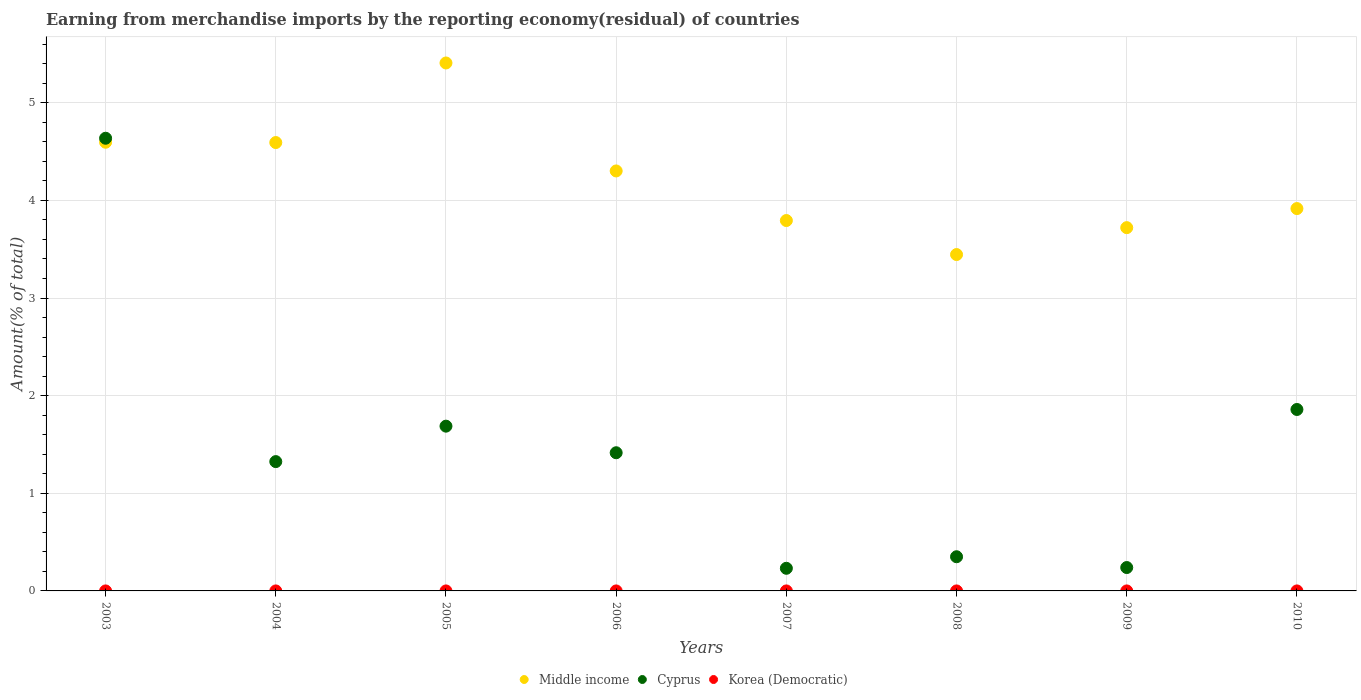How many different coloured dotlines are there?
Your response must be concise. 3. What is the percentage of amount earned from merchandise imports in Cyprus in 2006?
Provide a short and direct response. 1.42. Across all years, what is the maximum percentage of amount earned from merchandise imports in Korea (Democratic)?
Make the answer very short. 1.30511509646857e-8. Across all years, what is the minimum percentage of amount earned from merchandise imports in Cyprus?
Make the answer very short. 0.23. What is the total percentage of amount earned from merchandise imports in Korea (Democratic) in the graph?
Make the answer very short. 1.497962723188751e-8. What is the difference between the percentage of amount earned from merchandise imports in Cyprus in 2003 and that in 2010?
Ensure brevity in your answer.  2.78. What is the difference between the percentage of amount earned from merchandise imports in Middle income in 2006 and the percentage of amount earned from merchandise imports in Korea (Democratic) in 2004?
Your response must be concise. 4.3. What is the average percentage of amount earned from merchandise imports in Middle income per year?
Provide a short and direct response. 4.22. In the year 2004, what is the difference between the percentage of amount earned from merchandise imports in Cyprus and percentage of amount earned from merchandise imports in Middle income?
Your answer should be compact. -3.27. In how many years, is the percentage of amount earned from merchandise imports in Cyprus greater than 2.8 %?
Your answer should be very brief. 1. What is the ratio of the percentage of amount earned from merchandise imports in Cyprus in 2003 to that in 2009?
Offer a terse response. 19.36. Is the difference between the percentage of amount earned from merchandise imports in Cyprus in 2008 and 2010 greater than the difference between the percentage of amount earned from merchandise imports in Middle income in 2008 and 2010?
Your answer should be compact. No. What is the difference between the highest and the second highest percentage of amount earned from merchandise imports in Korea (Democratic)?
Give a very brief answer. 1.152774784415054e-8. What is the difference between the highest and the lowest percentage of amount earned from merchandise imports in Cyprus?
Make the answer very short. 4.41. Is it the case that in every year, the sum of the percentage of amount earned from merchandise imports in Korea (Democratic) and percentage of amount earned from merchandise imports in Middle income  is greater than the percentage of amount earned from merchandise imports in Cyprus?
Offer a very short reply. No. Is the percentage of amount earned from merchandise imports in Korea (Democratic) strictly greater than the percentage of amount earned from merchandise imports in Cyprus over the years?
Ensure brevity in your answer.  No. How many dotlines are there?
Your response must be concise. 3. How many years are there in the graph?
Offer a very short reply. 8. What is the difference between two consecutive major ticks on the Y-axis?
Provide a succinct answer. 1. Where does the legend appear in the graph?
Your answer should be compact. Bottom center. What is the title of the graph?
Provide a succinct answer. Earning from merchandise imports by the reporting economy(residual) of countries. Does "Italy" appear as one of the legend labels in the graph?
Make the answer very short. No. What is the label or title of the X-axis?
Provide a succinct answer. Years. What is the label or title of the Y-axis?
Offer a very short reply. Amount(% of total). What is the Amount(% of total) of Middle income in 2003?
Keep it short and to the point. 4.6. What is the Amount(% of total) of Cyprus in 2003?
Provide a succinct answer. 4.64. What is the Amount(% of total) of Korea (Democratic) in 2003?
Keep it short and to the point. 0. What is the Amount(% of total) of Middle income in 2004?
Provide a short and direct response. 4.59. What is the Amount(% of total) in Cyprus in 2004?
Keep it short and to the point. 1.32. What is the Amount(% of total) in Korea (Democratic) in 2004?
Your response must be concise. 1.30511509646857e-8. What is the Amount(% of total) in Middle income in 2005?
Make the answer very short. 5.41. What is the Amount(% of total) in Cyprus in 2005?
Offer a terse response. 1.69. What is the Amount(% of total) in Korea (Democratic) in 2005?
Offer a terse response. 0. What is the Amount(% of total) of Middle income in 2006?
Provide a short and direct response. 4.3. What is the Amount(% of total) of Cyprus in 2006?
Offer a terse response. 1.42. What is the Amount(% of total) in Korea (Democratic) in 2006?
Provide a succinct answer. 4.05073146666651e-10. What is the Amount(% of total) of Middle income in 2007?
Keep it short and to the point. 3.79. What is the Amount(% of total) of Cyprus in 2007?
Provide a succinct answer. 0.23. What is the Amount(% of total) of Middle income in 2008?
Your answer should be compact. 3.45. What is the Amount(% of total) in Cyprus in 2008?
Offer a terse response. 0.35. What is the Amount(% of total) of Middle income in 2009?
Offer a very short reply. 3.72. What is the Amount(% of total) in Cyprus in 2009?
Make the answer very short. 0.24. What is the Amount(% of total) in Korea (Democratic) in 2009?
Keep it short and to the point. 1.52340312053516e-9. What is the Amount(% of total) in Middle income in 2010?
Ensure brevity in your answer.  3.92. What is the Amount(% of total) of Cyprus in 2010?
Ensure brevity in your answer.  1.86. What is the Amount(% of total) of Korea (Democratic) in 2010?
Offer a very short reply. 0. Across all years, what is the maximum Amount(% of total) in Middle income?
Ensure brevity in your answer.  5.41. Across all years, what is the maximum Amount(% of total) of Cyprus?
Give a very brief answer. 4.64. Across all years, what is the maximum Amount(% of total) in Korea (Democratic)?
Offer a very short reply. 1.30511509646857e-8. Across all years, what is the minimum Amount(% of total) in Middle income?
Keep it short and to the point. 3.45. Across all years, what is the minimum Amount(% of total) of Cyprus?
Ensure brevity in your answer.  0.23. What is the total Amount(% of total) of Middle income in the graph?
Provide a succinct answer. 33.78. What is the total Amount(% of total) of Cyprus in the graph?
Offer a terse response. 11.74. What is the total Amount(% of total) of Korea (Democratic) in the graph?
Your response must be concise. 0. What is the difference between the Amount(% of total) in Middle income in 2003 and that in 2004?
Provide a short and direct response. 0. What is the difference between the Amount(% of total) of Cyprus in 2003 and that in 2004?
Ensure brevity in your answer.  3.31. What is the difference between the Amount(% of total) of Middle income in 2003 and that in 2005?
Your response must be concise. -0.81. What is the difference between the Amount(% of total) of Cyprus in 2003 and that in 2005?
Your answer should be very brief. 2.95. What is the difference between the Amount(% of total) in Middle income in 2003 and that in 2006?
Offer a very short reply. 0.29. What is the difference between the Amount(% of total) in Cyprus in 2003 and that in 2006?
Your answer should be compact. 3.22. What is the difference between the Amount(% of total) in Middle income in 2003 and that in 2007?
Keep it short and to the point. 0.8. What is the difference between the Amount(% of total) in Cyprus in 2003 and that in 2007?
Make the answer very short. 4.41. What is the difference between the Amount(% of total) in Middle income in 2003 and that in 2008?
Make the answer very short. 1.15. What is the difference between the Amount(% of total) of Cyprus in 2003 and that in 2008?
Your response must be concise. 4.29. What is the difference between the Amount(% of total) of Middle income in 2003 and that in 2009?
Provide a succinct answer. 0.87. What is the difference between the Amount(% of total) of Cyprus in 2003 and that in 2009?
Your response must be concise. 4.4. What is the difference between the Amount(% of total) in Middle income in 2003 and that in 2010?
Provide a succinct answer. 0.68. What is the difference between the Amount(% of total) in Cyprus in 2003 and that in 2010?
Make the answer very short. 2.78. What is the difference between the Amount(% of total) of Middle income in 2004 and that in 2005?
Give a very brief answer. -0.82. What is the difference between the Amount(% of total) in Cyprus in 2004 and that in 2005?
Offer a terse response. -0.36. What is the difference between the Amount(% of total) of Middle income in 2004 and that in 2006?
Ensure brevity in your answer.  0.29. What is the difference between the Amount(% of total) in Cyprus in 2004 and that in 2006?
Your response must be concise. -0.09. What is the difference between the Amount(% of total) in Korea (Democratic) in 2004 and that in 2006?
Keep it short and to the point. 0. What is the difference between the Amount(% of total) in Middle income in 2004 and that in 2007?
Your answer should be compact. 0.8. What is the difference between the Amount(% of total) of Cyprus in 2004 and that in 2007?
Your answer should be compact. 1.09. What is the difference between the Amount(% of total) in Middle income in 2004 and that in 2008?
Provide a succinct answer. 1.15. What is the difference between the Amount(% of total) of Cyprus in 2004 and that in 2008?
Ensure brevity in your answer.  0.97. What is the difference between the Amount(% of total) in Middle income in 2004 and that in 2009?
Make the answer very short. 0.87. What is the difference between the Amount(% of total) of Cyprus in 2004 and that in 2009?
Give a very brief answer. 1.09. What is the difference between the Amount(% of total) of Middle income in 2004 and that in 2010?
Provide a short and direct response. 0.68. What is the difference between the Amount(% of total) of Cyprus in 2004 and that in 2010?
Keep it short and to the point. -0.53. What is the difference between the Amount(% of total) of Middle income in 2005 and that in 2006?
Keep it short and to the point. 1.11. What is the difference between the Amount(% of total) of Cyprus in 2005 and that in 2006?
Ensure brevity in your answer.  0.27. What is the difference between the Amount(% of total) in Middle income in 2005 and that in 2007?
Make the answer very short. 1.61. What is the difference between the Amount(% of total) in Cyprus in 2005 and that in 2007?
Provide a short and direct response. 1.46. What is the difference between the Amount(% of total) in Middle income in 2005 and that in 2008?
Ensure brevity in your answer.  1.96. What is the difference between the Amount(% of total) of Cyprus in 2005 and that in 2008?
Give a very brief answer. 1.34. What is the difference between the Amount(% of total) in Middle income in 2005 and that in 2009?
Give a very brief answer. 1.69. What is the difference between the Amount(% of total) in Cyprus in 2005 and that in 2009?
Give a very brief answer. 1.45. What is the difference between the Amount(% of total) in Middle income in 2005 and that in 2010?
Offer a terse response. 1.49. What is the difference between the Amount(% of total) in Cyprus in 2005 and that in 2010?
Your answer should be very brief. -0.17. What is the difference between the Amount(% of total) in Middle income in 2006 and that in 2007?
Give a very brief answer. 0.51. What is the difference between the Amount(% of total) of Cyprus in 2006 and that in 2007?
Provide a succinct answer. 1.18. What is the difference between the Amount(% of total) in Middle income in 2006 and that in 2008?
Offer a terse response. 0.86. What is the difference between the Amount(% of total) of Cyprus in 2006 and that in 2008?
Give a very brief answer. 1.07. What is the difference between the Amount(% of total) in Middle income in 2006 and that in 2009?
Offer a terse response. 0.58. What is the difference between the Amount(% of total) in Cyprus in 2006 and that in 2009?
Your answer should be very brief. 1.18. What is the difference between the Amount(% of total) of Middle income in 2006 and that in 2010?
Your response must be concise. 0.39. What is the difference between the Amount(% of total) of Cyprus in 2006 and that in 2010?
Give a very brief answer. -0.44. What is the difference between the Amount(% of total) of Middle income in 2007 and that in 2008?
Your answer should be very brief. 0.35. What is the difference between the Amount(% of total) in Cyprus in 2007 and that in 2008?
Keep it short and to the point. -0.12. What is the difference between the Amount(% of total) of Middle income in 2007 and that in 2009?
Your answer should be very brief. 0.07. What is the difference between the Amount(% of total) in Cyprus in 2007 and that in 2009?
Provide a succinct answer. -0.01. What is the difference between the Amount(% of total) in Middle income in 2007 and that in 2010?
Keep it short and to the point. -0.12. What is the difference between the Amount(% of total) of Cyprus in 2007 and that in 2010?
Your answer should be compact. -1.63. What is the difference between the Amount(% of total) in Middle income in 2008 and that in 2009?
Offer a terse response. -0.28. What is the difference between the Amount(% of total) of Cyprus in 2008 and that in 2009?
Offer a terse response. 0.11. What is the difference between the Amount(% of total) of Middle income in 2008 and that in 2010?
Keep it short and to the point. -0.47. What is the difference between the Amount(% of total) of Cyprus in 2008 and that in 2010?
Keep it short and to the point. -1.51. What is the difference between the Amount(% of total) in Middle income in 2009 and that in 2010?
Ensure brevity in your answer.  -0.2. What is the difference between the Amount(% of total) in Cyprus in 2009 and that in 2010?
Give a very brief answer. -1.62. What is the difference between the Amount(% of total) in Middle income in 2003 and the Amount(% of total) in Cyprus in 2004?
Provide a succinct answer. 3.27. What is the difference between the Amount(% of total) in Middle income in 2003 and the Amount(% of total) in Korea (Democratic) in 2004?
Keep it short and to the point. 4.6. What is the difference between the Amount(% of total) in Cyprus in 2003 and the Amount(% of total) in Korea (Democratic) in 2004?
Offer a terse response. 4.64. What is the difference between the Amount(% of total) in Middle income in 2003 and the Amount(% of total) in Cyprus in 2005?
Your answer should be compact. 2.91. What is the difference between the Amount(% of total) of Middle income in 2003 and the Amount(% of total) of Cyprus in 2006?
Your answer should be very brief. 3.18. What is the difference between the Amount(% of total) of Middle income in 2003 and the Amount(% of total) of Korea (Democratic) in 2006?
Your answer should be very brief. 4.6. What is the difference between the Amount(% of total) of Cyprus in 2003 and the Amount(% of total) of Korea (Democratic) in 2006?
Your answer should be very brief. 4.64. What is the difference between the Amount(% of total) in Middle income in 2003 and the Amount(% of total) in Cyprus in 2007?
Give a very brief answer. 4.36. What is the difference between the Amount(% of total) in Middle income in 2003 and the Amount(% of total) in Cyprus in 2008?
Give a very brief answer. 4.25. What is the difference between the Amount(% of total) in Middle income in 2003 and the Amount(% of total) in Cyprus in 2009?
Your response must be concise. 4.36. What is the difference between the Amount(% of total) in Middle income in 2003 and the Amount(% of total) in Korea (Democratic) in 2009?
Your response must be concise. 4.6. What is the difference between the Amount(% of total) of Cyprus in 2003 and the Amount(% of total) of Korea (Democratic) in 2009?
Provide a succinct answer. 4.64. What is the difference between the Amount(% of total) in Middle income in 2003 and the Amount(% of total) in Cyprus in 2010?
Make the answer very short. 2.74. What is the difference between the Amount(% of total) of Middle income in 2004 and the Amount(% of total) of Cyprus in 2005?
Keep it short and to the point. 2.91. What is the difference between the Amount(% of total) in Middle income in 2004 and the Amount(% of total) in Cyprus in 2006?
Your answer should be compact. 3.18. What is the difference between the Amount(% of total) in Middle income in 2004 and the Amount(% of total) in Korea (Democratic) in 2006?
Keep it short and to the point. 4.59. What is the difference between the Amount(% of total) in Cyprus in 2004 and the Amount(% of total) in Korea (Democratic) in 2006?
Give a very brief answer. 1.32. What is the difference between the Amount(% of total) in Middle income in 2004 and the Amount(% of total) in Cyprus in 2007?
Your answer should be very brief. 4.36. What is the difference between the Amount(% of total) in Middle income in 2004 and the Amount(% of total) in Cyprus in 2008?
Give a very brief answer. 4.24. What is the difference between the Amount(% of total) of Middle income in 2004 and the Amount(% of total) of Cyprus in 2009?
Ensure brevity in your answer.  4.35. What is the difference between the Amount(% of total) in Middle income in 2004 and the Amount(% of total) in Korea (Democratic) in 2009?
Your answer should be compact. 4.59. What is the difference between the Amount(% of total) in Cyprus in 2004 and the Amount(% of total) in Korea (Democratic) in 2009?
Give a very brief answer. 1.32. What is the difference between the Amount(% of total) in Middle income in 2004 and the Amount(% of total) in Cyprus in 2010?
Ensure brevity in your answer.  2.73. What is the difference between the Amount(% of total) in Middle income in 2005 and the Amount(% of total) in Cyprus in 2006?
Keep it short and to the point. 3.99. What is the difference between the Amount(% of total) of Middle income in 2005 and the Amount(% of total) of Korea (Democratic) in 2006?
Give a very brief answer. 5.41. What is the difference between the Amount(% of total) in Cyprus in 2005 and the Amount(% of total) in Korea (Democratic) in 2006?
Keep it short and to the point. 1.69. What is the difference between the Amount(% of total) in Middle income in 2005 and the Amount(% of total) in Cyprus in 2007?
Your answer should be compact. 5.18. What is the difference between the Amount(% of total) in Middle income in 2005 and the Amount(% of total) in Cyprus in 2008?
Provide a succinct answer. 5.06. What is the difference between the Amount(% of total) of Middle income in 2005 and the Amount(% of total) of Cyprus in 2009?
Give a very brief answer. 5.17. What is the difference between the Amount(% of total) in Middle income in 2005 and the Amount(% of total) in Korea (Democratic) in 2009?
Your response must be concise. 5.41. What is the difference between the Amount(% of total) of Cyprus in 2005 and the Amount(% of total) of Korea (Democratic) in 2009?
Keep it short and to the point. 1.69. What is the difference between the Amount(% of total) of Middle income in 2005 and the Amount(% of total) of Cyprus in 2010?
Give a very brief answer. 3.55. What is the difference between the Amount(% of total) of Middle income in 2006 and the Amount(% of total) of Cyprus in 2007?
Ensure brevity in your answer.  4.07. What is the difference between the Amount(% of total) of Middle income in 2006 and the Amount(% of total) of Cyprus in 2008?
Make the answer very short. 3.95. What is the difference between the Amount(% of total) of Middle income in 2006 and the Amount(% of total) of Cyprus in 2009?
Your answer should be compact. 4.06. What is the difference between the Amount(% of total) in Middle income in 2006 and the Amount(% of total) in Korea (Democratic) in 2009?
Offer a very short reply. 4.3. What is the difference between the Amount(% of total) in Cyprus in 2006 and the Amount(% of total) in Korea (Democratic) in 2009?
Offer a terse response. 1.42. What is the difference between the Amount(% of total) of Middle income in 2006 and the Amount(% of total) of Cyprus in 2010?
Keep it short and to the point. 2.44. What is the difference between the Amount(% of total) of Middle income in 2007 and the Amount(% of total) of Cyprus in 2008?
Provide a succinct answer. 3.44. What is the difference between the Amount(% of total) of Middle income in 2007 and the Amount(% of total) of Cyprus in 2009?
Your response must be concise. 3.55. What is the difference between the Amount(% of total) of Middle income in 2007 and the Amount(% of total) of Korea (Democratic) in 2009?
Your response must be concise. 3.79. What is the difference between the Amount(% of total) in Cyprus in 2007 and the Amount(% of total) in Korea (Democratic) in 2009?
Ensure brevity in your answer.  0.23. What is the difference between the Amount(% of total) in Middle income in 2007 and the Amount(% of total) in Cyprus in 2010?
Your answer should be compact. 1.94. What is the difference between the Amount(% of total) in Middle income in 2008 and the Amount(% of total) in Cyprus in 2009?
Your answer should be very brief. 3.21. What is the difference between the Amount(% of total) of Middle income in 2008 and the Amount(% of total) of Korea (Democratic) in 2009?
Provide a succinct answer. 3.45. What is the difference between the Amount(% of total) of Cyprus in 2008 and the Amount(% of total) of Korea (Democratic) in 2009?
Give a very brief answer. 0.35. What is the difference between the Amount(% of total) of Middle income in 2008 and the Amount(% of total) of Cyprus in 2010?
Offer a very short reply. 1.59. What is the difference between the Amount(% of total) in Middle income in 2009 and the Amount(% of total) in Cyprus in 2010?
Your answer should be very brief. 1.86. What is the average Amount(% of total) in Middle income per year?
Offer a terse response. 4.22. What is the average Amount(% of total) of Cyprus per year?
Your response must be concise. 1.47. What is the average Amount(% of total) in Korea (Democratic) per year?
Keep it short and to the point. 0. In the year 2003, what is the difference between the Amount(% of total) of Middle income and Amount(% of total) of Cyprus?
Ensure brevity in your answer.  -0.04. In the year 2004, what is the difference between the Amount(% of total) in Middle income and Amount(% of total) in Cyprus?
Make the answer very short. 3.27. In the year 2004, what is the difference between the Amount(% of total) of Middle income and Amount(% of total) of Korea (Democratic)?
Keep it short and to the point. 4.59. In the year 2004, what is the difference between the Amount(% of total) in Cyprus and Amount(% of total) in Korea (Democratic)?
Your response must be concise. 1.32. In the year 2005, what is the difference between the Amount(% of total) of Middle income and Amount(% of total) of Cyprus?
Offer a terse response. 3.72. In the year 2006, what is the difference between the Amount(% of total) of Middle income and Amount(% of total) of Cyprus?
Provide a succinct answer. 2.89. In the year 2006, what is the difference between the Amount(% of total) in Middle income and Amount(% of total) in Korea (Democratic)?
Ensure brevity in your answer.  4.3. In the year 2006, what is the difference between the Amount(% of total) of Cyprus and Amount(% of total) of Korea (Democratic)?
Ensure brevity in your answer.  1.42. In the year 2007, what is the difference between the Amount(% of total) of Middle income and Amount(% of total) of Cyprus?
Offer a very short reply. 3.56. In the year 2008, what is the difference between the Amount(% of total) in Middle income and Amount(% of total) in Cyprus?
Offer a very short reply. 3.1. In the year 2009, what is the difference between the Amount(% of total) in Middle income and Amount(% of total) in Cyprus?
Make the answer very short. 3.48. In the year 2009, what is the difference between the Amount(% of total) of Middle income and Amount(% of total) of Korea (Democratic)?
Provide a succinct answer. 3.72. In the year 2009, what is the difference between the Amount(% of total) of Cyprus and Amount(% of total) of Korea (Democratic)?
Your response must be concise. 0.24. In the year 2010, what is the difference between the Amount(% of total) in Middle income and Amount(% of total) in Cyprus?
Provide a succinct answer. 2.06. What is the ratio of the Amount(% of total) in Middle income in 2003 to that in 2004?
Your answer should be very brief. 1. What is the ratio of the Amount(% of total) of Cyprus in 2003 to that in 2004?
Your answer should be compact. 3.5. What is the ratio of the Amount(% of total) in Middle income in 2003 to that in 2005?
Offer a very short reply. 0.85. What is the ratio of the Amount(% of total) of Cyprus in 2003 to that in 2005?
Offer a terse response. 2.75. What is the ratio of the Amount(% of total) in Middle income in 2003 to that in 2006?
Your response must be concise. 1.07. What is the ratio of the Amount(% of total) in Cyprus in 2003 to that in 2006?
Provide a short and direct response. 3.28. What is the ratio of the Amount(% of total) in Middle income in 2003 to that in 2007?
Your response must be concise. 1.21. What is the ratio of the Amount(% of total) in Cyprus in 2003 to that in 2007?
Your response must be concise. 20.01. What is the ratio of the Amount(% of total) in Middle income in 2003 to that in 2008?
Provide a succinct answer. 1.33. What is the ratio of the Amount(% of total) of Cyprus in 2003 to that in 2008?
Ensure brevity in your answer.  13.25. What is the ratio of the Amount(% of total) of Middle income in 2003 to that in 2009?
Make the answer very short. 1.24. What is the ratio of the Amount(% of total) in Cyprus in 2003 to that in 2009?
Offer a very short reply. 19.36. What is the ratio of the Amount(% of total) in Middle income in 2003 to that in 2010?
Provide a succinct answer. 1.17. What is the ratio of the Amount(% of total) of Cyprus in 2003 to that in 2010?
Keep it short and to the point. 2.49. What is the ratio of the Amount(% of total) of Middle income in 2004 to that in 2005?
Offer a very short reply. 0.85. What is the ratio of the Amount(% of total) in Cyprus in 2004 to that in 2005?
Make the answer very short. 0.78. What is the ratio of the Amount(% of total) of Middle income in 2004 to that in 2006?
Offer a very short reply. 1.07. What is the ratio of the Amount(% of total) in Cyprus in 2004 to that in 2006?
Your answer should be very brief. 0.94. What is the ratio of the Amount(% of total) in Korea (Democratic) in 2004 to that in 2006?
Offer a terse response. 32.22. What is the ratio of the Amount(% of total) of Middle income in 2004 to that in 2007?
Provide a succinct answer. 1.21. What is the ratio of the Amount(% of total) in Cyprus in 2004 to that in 2007?
Ensure brevity in your answer.  5.72. What is the ratio of the Amount(% of total) in Middle income in 2004 to that in 2008?
Your answer should be compact. 1.33. What is the ratio of the Amount(% of total) of Cyprus in 2004 to that in 2008?
Ensure brevity in your answer.  3.78. What is the ratio of the Amount(% of total) in Middle income in 2004 to that in 2009?
Ensure brevity in your answer.  1.23. What is the ratio of the Amount(% of total) of Cyprus in 2004 to that in 2009?
Give a very brief answer. 5.53. What is the ratio of the Amount(% of total) of Korea (Democratic) in 2004 to that in 2009?
Your answer should be compact. 8.57. What is the ratio of the Amount(% of total) of Middle income in 2004 to that in 2010?
Make the answer very short. 1.17. What is the ratio of the Amount(% of total) in Cyprus in 2004 to that in 2010?
Provide a succinct answer. 0.71. What is the ratio of the Amount(% of total) of Middle income in 2005 to that in 2006?
Provide a succinct answer. 1.26. What is the ratio of the Amount(% of total) in Cyprus in 2005 to that in 2006?
Provide a short and direct response. 1.19. What is the ratio of the Amount(% of total) in Middle income in 2005 to that in 2007?
Make the answer very short. 1.43. What is the ratio of the Amount(% of total) of Cyprus in 2005 to that in 2007?
Offer a very short reply. 7.28. What is the ratio of the Amount(% of total) in Middle income in 2005 to that in 2008?
Provide a succinct answer. 1.57. What is the ratio of the Amount(% of total) in Cyprus in 2005 to that in 2008?
Provide a succinct answer. 4.82. What is the ratio of the Amount(% of total) of Middle income in 2005 to that in 2009?
Keep it short and to the point. 1.45. What is the ratio of the Amount(% of total) of Cyprus in 2005 to that in 2009?
Keep it short and to the point. 7.05. What is the ratio of the Amount(% of total) in Middle income in 2005 to that in 2010?
Your answer should be compact. 1.38. What is the ratio of the Amount(% of total) of Cyprus in 2005 to that in 2010?
Make the answer very short. 0.91. What is the ratio of the Amount(% of total) in Middle income in 2006 to that in 2007?
Your response must be concise. 1.13. What is the ratio of the Amount(% of total) in Cyprus in 2006 to that in 2007?
Offer a terse response. 6.11. What is the ratio of the Amount(% of total) in Middle income in 2006 to that in 2008?
Your answer should be very brief. 1.25. What is the ratio of the Amount(% of total) in Cyprus in 2006 to that in 2008?
Your answer should be very brief. 4.04. What is the ratio of the Amount(% of total) in Middle income in 2006 to that in 2009?
Your answer should be compact. 1.16. What is the ratio of the Amount(% of total) of Cyprus in 2006 to that in 2009?
Your answer should be compact. 5.91. What is the ratio of the Amount(% of total) in Korea (Democratic) in 2006 to that in 2009?
Offer a very short reply. 0.27. What is the ratio of the Amount(% of total) of Middle income in 2006 to that in 2010?
Ensure brevity in your answer.  1.1. What is the ratio of the Amount(% of total) of Cyprus in 2006 to that in 2010?
Give a very brief answer. 0.76. What is the ratio of the Amount(% of total) in Middle income in 2007 to that in 2008?
Your answer should be compact. 1.1. What is the ratio of the Amount(% of total) of Cyprus in 2007 to that in 2008?
Provide a short and direct response. 0.66. What is the ratio of the Amount(% of total) of Middle income in 2007 to that in 2009?
Your response must be concise. 1.02. What is the ratio of the Amount(% of total) in Middle income in 2007 to that in 2010?
Your answer should be very brief. 0.97. What is the ratio of the Amount(% of total) of Cyprus in 2007 to that in 2010?
Make the answer very short. 0.12. What is the ratio of the Amount(% of total) of Middle income in 2008 to that in 2009?
Provide a succinct answer. 0.93. What is the ratio of the Amount(% of total) in Cyprus in 2008 to that in 2009?
Offer a very short reply. 1.46. What is the ratio of the Amount(% of total) of Middle income in 2008 to that in 2010?
Provide a short and direct response. 0.88. What is the ratio of the Amount(% of total) of Cyprus in 2008 to that in 2010?
Offer a very short reply. 0.19. What is the ratio of the Amount(% of total) of Middle income in 2009 to that in 2010?
Your answer should be very brief. 0.95. What is the ratio of the Amount(% of total) of Cyprus in 2009 to that in 2010?
Keep it short and to the point. 0.13. What is the difference between the highest and the second highest Amount(% of total) in Middle income?
Your answer should be very brief. 0.81. What is the difference between the highest and the second highest Amount(% of total) in Cyprus?
Your response must be concise. 2.78. What is the difference between the highest and the second highest Amount(% of total) in Korea (Democratic)?
Offer a very short reply. 0. What is the difference between the highest and the lowest Amount(% of total) of Middle income?
Offer a very short reply. 1.96. What is the difference between the highest and the lowest Amount(% of total) of Cyprus?
Provide a succinct answer. 4.41. 